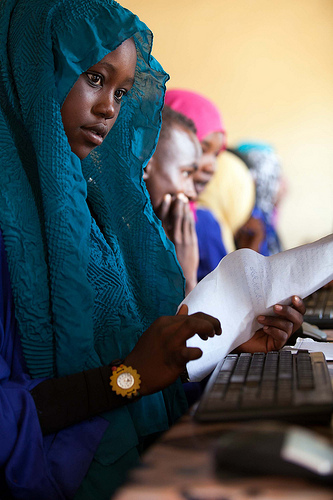<image>
Is the woman to the right of the man? Yes. From this viewpoint, the woman is positioned to the right side relative to the man. 